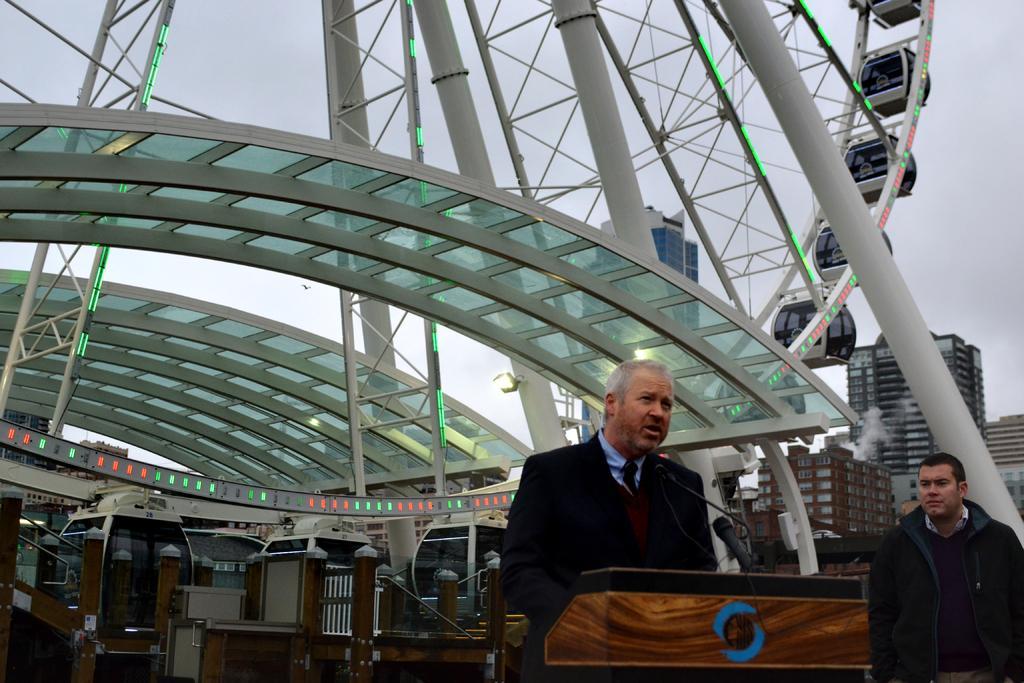Could you give a brief overview of what you see in this image? In this picture, on the right side, we can see a man standing. On the right side, we can also see another man standing in front of the podium and talking from the microphone. In the background, we can also see little buildings, electrical lights, pillars. On the top, we can see a roof, sky and a bird. 